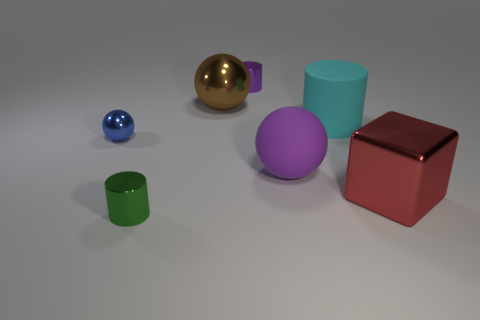How many objects are either tiny shiny cylinders that are in front of the big matte cylinder or cyan matte cylinders that are behind the small green cylinder?
Make the answer very short. 2. The cylinder in front of the large red metal object behind the small green metal cylinder is what color?
Offer a very short reply. Green. What color is the other object that is made of the same material as the cyan thing?
Offer a terse response. Purple. What number of large things are the same color as the big matte ball?
Your answer should be very brief. 0. How many things are either cyan rubber things or tiny green shiny spheres?
Offer a very short reply. 1. What shape is the brown metallic object that is the same size as the cyan cylinder?
Your answer should be very brief. Sphere. How many objects are in front of the big cube and behind the cube?
Your answer should be very brief. 0. What is the material of the tiny cylinder that is in front of the blue thing?
Give a very brief answer. Metal. There is a brown object that is the same material as the green object; what is its size?
Offer a terse response. Large. Does the rubber object on the left side of the cyan rubber thing have the same size as the blue metallic ball that is in front of the purple metallic cylinder?
Provide a succinct answer. No. 